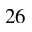<formula> <loc_0><loc_0><loc_500><loc_500>^ { 2 } 6</formula> 